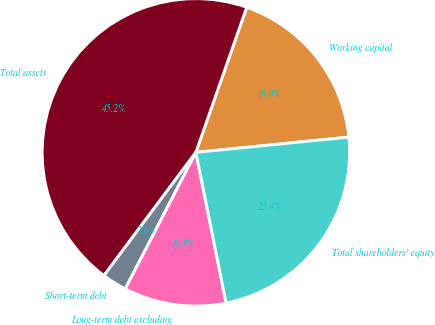<chart> <loc_0><loc_0><loc_500><loc_500><pie_chart><fcel>Working capital<fcel>Total assets<fcel>Short-term debt<fcel>Long-term debt excluding<fcel>Total shareholders' equity<nl><fcel>18.05%<fcel>45.17%<fcel>2.6%<fcel>10.75%<fcel>23.43%<nl></chart> 